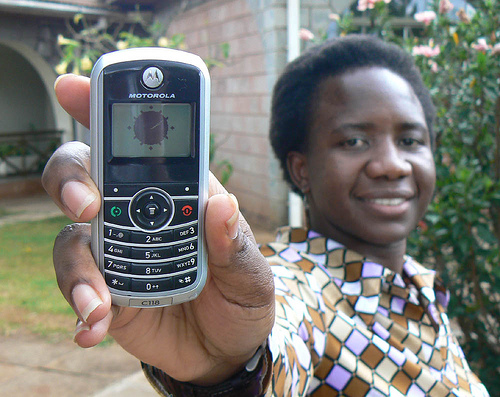Identify and read out the text in this image. MOTOROLA 1 2 3 4 WAYS? 0 5 6 9 8 7 